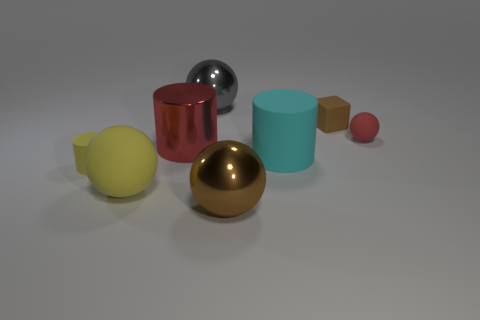What shape is the metallic thing that is right of the metal sphere that is behind the red sphere that is behind the yellow cylinder?
Provide a succinct answer. Sphere. What number of other objects are the same material as the large cyan thing?
Your response must be concise. 4. What number of things are metallic spheres that are behind the big shiny cylinder or blue matte cylinders?
Provide a succinct answer. 1. There is a red thing that is to the left of the metal sphere that is behind the yellow matte cylinder; what is its shape?
Your answer should be compact. Cylinder. There is a metallic object that is behind the tiny brown cube; is it the same shape as the big yellow matte thing?
Offer a very short reply. Yes. The metallic sphere in front of the red metal object is what color?
Your response must be concise. Brown. What number of cylinders are either red things or red rubber objects?
Make the answer very short. 1. What size is the shiny sphere that is behind the small thing on the left side of the large yellow sphere?
Make the answer very short. Large. There is a cube; is it the same color as the shiny ball in front of the red metallic object?
Keep it short and to the point. Yes. There is a yellow matte sphere; what number of rubber balls are behind it?
Ensure brevity in your answer.  1. 